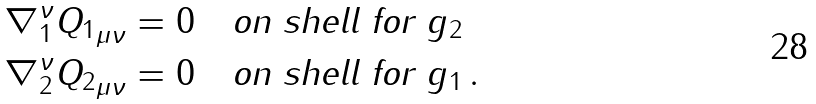<formula> <loc_0><loc_0><loc_500><loc_500>& \nabla _ { 1 } ^ { \nu } { Q _ { 1 } } _ { \mu \nu } = 0 \quad \text {on shell for } g _ { 2 } \\ & \nabla _ { 2 } ^ { \nu } { Q _ { 2 } } _ { \mu \nu } = 0 \quad \text {on shell for } g _ { 1 } \, .</formula> 